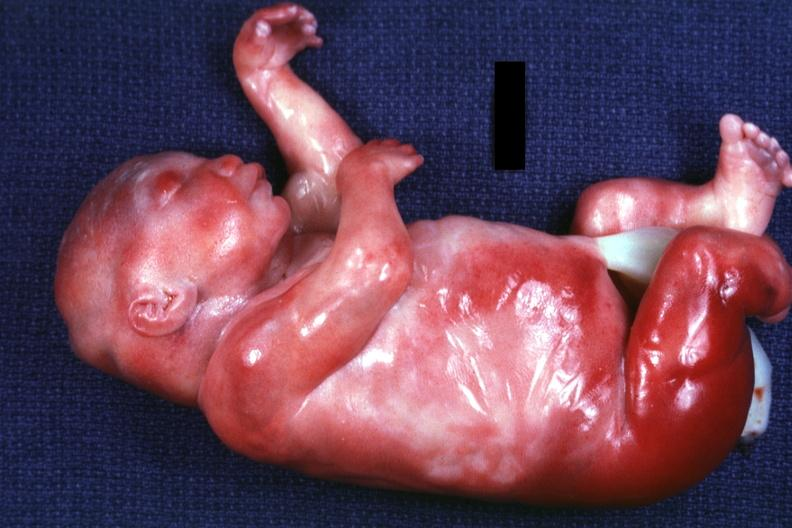what appear too short?
Answer the question using a single word or phrase. No neck and a barely seen vascular mass extruding from occipital region of skull arms and legs 